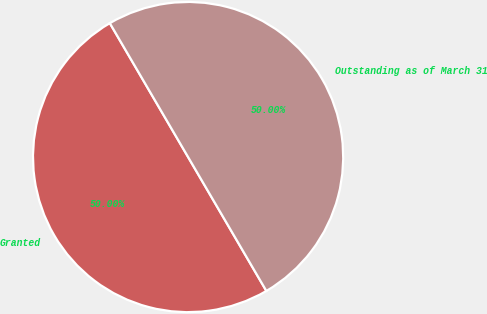Convert chart to OTSL. <chart><loc_0><loc_0><loc_500><loc_500><pie_chart><fcel>Granted<fcel>Outstanding as of March 31<nl><fcel>50.0%<fcel>50.0%<nl></chart> 